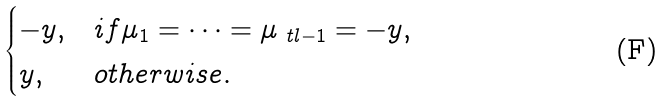Convert formula to latex. <formula><loc_0><loc_0><loc_500><loc_500>\begin{cases} - y , & i f \mu _ { 1 } = \cdots = \mu _ { \ t l - 1 } = - y , \\ y , & o t h e r w i s e . \end{cases}</formula> 